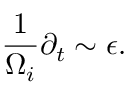<formula> <loc_0><loc_0><loc_500><loc_500>\frac { 1 } { \Omega _ { i } } \partial _ { t } \sim \epsilon .</formula> 